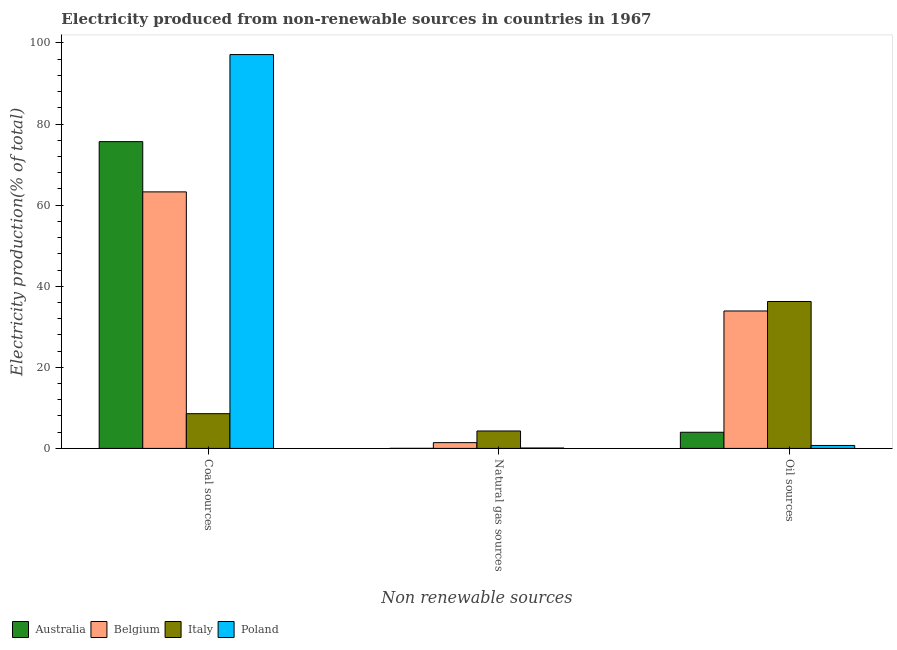Are the number of bars on each tick of the X-axis equal?
Provide a short and direct response. Yes. How many bars are there on the 2nd tick from the right?
Provide a short and direct response. 4. What is the label of the 2nd group of bars from the left?
Provide a short and direct response. Natural gas sources. What is the percentage of electricity produced by coal in Poland?
Your answer should be compact. 97.14. Across all countries, what is the maximum percentage of electricity produced by coal?
Keep it short and to the point. 97.14. Across all countries, what is the minimum percentage of electricity produced by oil sources?
Offer a terse response. 0.73. What is the total percentage of electricity produced by oil sources in the graph?
Keep it short and to the point. 74.85. What is the difference between the percentage of electricity produced by natural gas in Italy and that in Australia?
Your answer should be compact. 4.28. What is the difference between the percentage of electricity produced by coal in Belgium and the percentage of electricity produced by oil sources in Australia?
Offer a very short reply. 59.29. What is the average percentage of electricity produced by coal per country?
Your answer should be compact. 61.16. What is the difference between the percentage of electricity produced by coal and percentage of electricity produced by oil sources in Italy?
Keep it short and to the point. -27.67. In how many countries, is the percentage of electricity produced by oil sources greater than 80 %?
Give a very brief answer. 0. What is the ratio of the percentage of electricity produced by coal in Belgium to that in Poland?
Offer a terse response. 0.65. Is the difference between the percentage of electricity produced by oil sources in Italy and Poland greater than the difference between the percentage of electricity produced by coal in Italy and Poland?
Offer a terse response. Yes. What is the difference between the highest and the second highest percentage of electricity produced by natural gas?
Offer a very short reply. 2.87. What is the difference between the highest and the lowest percentage of electricity produced by natural gas?
Give a very brief answer. 4.28. In how many countries, is the percentage of electricity produced by oil sources greater than the average percentage of electricity produced by oil sources taken over all countries?
Keep it short and to the point. 2. Is the sum of the percentage of electricity produced by oil sources in Poland and Belgium greater than the maximum percentage of electricity produced by natural gas across all countries?
Your answer should be compact. Yes. What does the 3rd bar from the left in Natural gas sources represents?
Give a very brief answer. Italy. What does the 4th bar from the right in Coal sources represents?
Provide a short and direct response. Australia. How many bars are there?
Give a very brief answer. 12. How many countries are there in the graph?
Offer a very short reply. 4. Where does the legend appear in the graph?
Give a very brief answer. Bottom left. How many legend labels are there?
Provide a succinct answer. 4. How are the legend labels stacked?
Provide a succinct answer. Horizontal. What is the title of the graph?
Your answer should be very brief. Electricity produced from non-renewable sources in countries in 1967. What is the label or title of the X-axis?
Your response must be concise. Non renewable sources. What is the Electricity production(% of total) of Australia in Coal sources?
Ensure brevity in your answer.  75.67. What is the Electricity production(% of total) of Belgium in Coal sources?
Your answer should be very brief. 63.27. What is the Electricity production(% of total) of Italy in Coal sources?
Your answer should be very brief. 8.57. What is the Electricity production(% of total) of Poland in Coal sources?
Your response must be concise. 97.14. What is the Electricity production(% of total) of Australia in Natural gas sources?
Give a very brief answer. 0.02. What is the Electricity production(% of total) in Belgium in Natural gas sources?
Provide a short and direct response. 1.43. What is the Electricity production(% of total) in Italy in Natural gas sources?
Offer a very short reply. 4.3. What is the Electricity production(% of total) in Poland in Natural gas sources?
Offer a very short reply. 0.1. What is the Electricity production(% of total) of Australia in Oil sources?
Ensure brevity in your answer.  3.98. What is the Electricity production(% of total) in Belgium in Oil sources?
Ensure brevity in your answer.  33.9. What is the Electricity production(% of total) in Italy in Oil sources?
Give a very brief answer. 36.24. What is the Electricity production(% of total) in Poland in Oil sources?
Ensure brevity in your answer.  0.73. Across all Non renewable sources, what is the maximum Electricity production(% of total) in Australia?
Give a very brief answer. 75.67. Across all Non renewable sources, what is the maximum Electricity production(% of total) of Belgium?
Give a very brief answer. 63.27. Across all Non renewable sources, what is the maximum Electricity production(% of total) in Italy?
Ensure brevity in your answer.  36.24. Across all Non renewable sources, what is the maximum Electricity production(% of total) in Poland?
Give a very brief answer. 97.14. Across all Non renewable sources, what is the minimum Electricity production(% of total) in Australia?
Your answer should be compact. 0.02. Across all Non renewable sources, what is the minimum Electricity production(% of total) of Belgium?
Give a very brief answer. 1.43. Across all Non renewable sources, what is the minimum Electricity production(% of total) of Italy?
Keep it short and to the point. 4.3. Across all Non renewable sources, what is the minimum Electricity production(% of total) of Poland?
Offer a terse response. 0.1. What is the total Electricity production(% of total) of Australia in the graph?
Make the answer very short. 79.67. What is the total Electricity production(% of total) in Belgium in the graph?
Offer a terse response. 98.6. What is the total Electricity production(% of total) in Italy in the graph?
Provide a succinct answer. 49.11. What is the total Electricity production(% of total) in Poland in the graph?
Make the answer very short. 97.97. What is the difference between the Electricity production(% of total) in Australia in Coal sources and that in Natural gas sources?
Your answer should be very brief. 75.65. What is the difference between the Electricity production(% of total) of Belgium in Coal sources and that in Natural gas sources?
Keep it short and to the point. 61.85. What is the difference between the Electricity production(% of total) of Italy in Coal sources and that in Natural gas sources?
Provide a short and direct response. 4.27. What is the difference between the Electricity production(% of total) in Poland in Coal sources and that in Natural gas sources?
Your answer should be compact. 97.04. What is the difference between the Electricity production(% of total) in Australia in Coal sources and that in Oil sources?
Your response must be concise. 71.68. What is the difference between the Electricity production(% of total) in Belgium in Coal sources and that in Oil sources?
Your answer should be compact. 29.37. What is the difference between the Electricity production(% of total) in Italy in Coal sources and that in Oil sources?
Your answer should be very brief. -27.67. What is the difference between the Electricity production(% of total) in Poland in Coal sources and that in Oil sources?
Provide a succinct answer. 96.41. What is the difference between the Electricity production(% of total) of Australia in Natural gas sources and that in Oil sources?
Your answer should be compact. -3.96. What is the difference between the Electricity production(% of total) in Belgium in Natural gas sources and that in Oil sources?
Make the answer very short. -32.47. What is the difference between the Electricity production(% of total) of Italy in Natural gas sources and that in Oil sources?
Give a very brief answer. -31.94. What is the difference between the Electricity production(% of total) of Poland in Natural gas sources and that in Oil sources?
Offer a terse response. -0.63. What is the difference between the Electricity production(% of total) of Australia in Coal sources and the Electricity production(% of total) of Belgium in Natural gas sources?
Make the answer very short. 74.24. What is the difference between the Electricity production(% of total) of Australia in Coal sources and the Electricity production(% of total) of Italy in Natural gas sources?
Provide a short and direct response. 71.37. What is the difference between the Electricity production(% of total) of Australia in Coal sources and the Electricity production(% of total) of Poland in Natural gas sources?
Ensure brevity in your answer.  75.57. What is the difference between the Electricity production(% of total) of Belgium in Coal sources and the Electricity production(% of total) of Italy in Natural gas sources?
Provide a succinct answer. 58.97. What is the difference between the Electricity production(% of total) of Belgium in Coal sources and the Electricity production(% of total) of Poland in Natural gas sources?
Keep it short and to the point. 63.17. What is the difference between the Electricity production(% of total) in Italy in Coal sources and the Electricity production(% of total) in Poland in Natural gas sources?
Offer a very short reply. 8.47. What is the difference between the Electricity production(% of total) in Australia in Coal sources and the Electricity production(% of total) in Belgium in Oil sources?
Give a very brief answer. 41.77. What is the difference between the Electricity production(% of total) in Australia in Coal sources and the Electricity production(% of total) in Italy in Oil sources?
Offer a terse response. 39.43. What is the difference between the Electricity production(% of total) of Australia in Coal sources and the Electricity production(% of total) of Poland in Oil sources?
Give a very brief answer. 74.94. What is the difference between the Electricity production(% of total) of Belgium in Coal sources and the Electricity production(% of total) of Italy in Oil sources?
Ensure brevity in your answer.  27.03. What is the difference between the Electricity production(% of total) in Belgium in Coal sources and the Electricity production(% of total) in Poland in Oil sources?
Your answer should be very brief. 62.54. What is the difference between the Electricity production(% of total) in Italy in Coal sources and the Electricity production(% of total) in Poland in Oil sources?
Your answer should be compact. 7.84. What is the difference between the Electricity production(% of total) in Australia in Natural gas sources and the Electricity production(% of total) in Belgium in Oil sources?
Your answer should be very brief. -33.88. What is the difference between the Electricity production(% of total) in Australia in Natural gas sources and the Electricity production(% of total) in Italy in Oil sources?
Keep it short and to the point. -36.22. What is the difference between the Electricity production(% of total) of Australia in Natural gas sources and the Electricity production(% of total) of Poland in Oil sources?
Offer a very short reply. -0.71. What is the difference between the Electricity production(% of total) of Belgium in Natural gas sources and the Electricity production(% of total) of Italy in Oil sources?
Your answer should be compact. -34.81. What is the difference between the Electricity production(% of total) in Belgium in Natural gas sources and the Electricity production(% of total) in Poland in Oil sources?
Your answer should be very brief. 0.7. What is the difference between the Electricity production(% of total) of Italy in Natural gas sources and the Electricity production(% of total) of Poland in Oil sources?
Your answer should be compact. 3.57. What is the average Electricity production(% of total) of Australia per Non renewable sources?
Offer a very short reply. 26.56. What is the average Electricity production(% of total) of Belgium per Non renewable sources?
Give a very brief answer. 32.87. What is the average Electricity production(% of total) in Italy per Non renewable sources?
Ensure brevity in your answer.  16.37. What is the average Electricity production(% of total) of Poland per Non renewable sources?
Keep it short and to the point. 32.66. What is the difference between the Electricity production(% of total) of Australia and Electricity production(% of total) of Belgium in Coal sources?
Offer a terse response. 12.39. What is the difference between the Electricity production(% of total) of Australia and Electricity production(% of total) of Italy in Coal sources?
Provide a short and direct response. 67.1. What is the difference between the Electricity production(% of total) in Australia and Electricity production(% of total) in Poland in Coal sources?
Your answer should be compact. -21.47. What is the difference between the Electricity production(% of total) in Belgium and Electricity production(% of total) in Italy in Coal sources?
Give a very brief answer. 54.7. What is the difference between the Electricity production(% of total) in Belgium and Electricity production(% of total) in Poland in Coal sources?
Provide a succinct answer. -33.87. What is the difference between the Electricity production(% of total) of Italy and Electricity production(% of total) of Poland in Coal sources?
Give a very brief answer. -88.57. What is the difference between the Electricity production(% of total) of Australia and Electricity production(% of total) of Belgium in Natural gas sources?
Make the answer very short. -1.41. What is the difference between the Electricity production(% of total) of Australia and Electricity production(% of total) of Italy in Natural gas sources?
Provide a short and direct response. -4.28. What is the difference between the Electricity production(% of total) of Australia and Electricity production(% of total) of Poland in Natural gas sources?
Your answer should be very brief. -0.08. What is the difference between the Electricity production(% of total) of Belgium and Electricity production(% of total) of Italy in Natural gas sources?
Give a very brief answer. -2.87. What is the difference between the Electricity production(% of total) of Belgium and Electricity production(% of total) of Poland in Natural gas sources?
Offer a terse response. 1.33. What is the difference between the Electricity production(% of total) of Italy and Electricity production(% of total) of Poland in Natural gas sources?
Make the answer very short. 4.2. What is the difference between the Electricity production(% of total) in Australia and Electricity production(% of total) in Belgium in Oil sources?
Your response must be concise. -29.91. What is the difference between the Electricity production(% of total) in Australia and Electricity production(% of total) in Italy in Oil sources?
Keep it short and to the point. -32.25. What is the difference between the Electricity production(% of total) in Australia and Electricity production(% of total) in Poland in Oil sources?
Make the answer very short. 3.25. What is the difference between the Electricity production(% of total) in Belgium and Electricity production(% of total) in Italy in Oil sources?
Ensure brevity in your answer.  -2.34. What is the difference between the Electricity production(% of total) of Belgium and Electricity production(% of total) of Poland in Oil sources?
Keep it short and to the point. 33.17. What is the difference between the Electricity production(% of total) of Italy and Electricity production(% of total) of Poland in Oil sources?
Offer a very short reply. 35.51. What is the ratio of the Electricity production(% of total) of Australia in Coal sources to that in Natural gas sources?
Ensure brevity in your answer.  3681.5. What is the ratio of the Electricity production(% of total) in Belgium in Coal sources to that in Natural gas sources?
Give a very brief answer. 44.35. What is the ratio of the Electricity production(% of total) in Italy in Coal sources to that in Natural gas sources?
Your answer should be compact. 1.99. What is the ratio of the Electricity production(% of total) of Poland in Coal sources to that in Natural gas sources?
Keep it short and to the point. 956.85. What is the ratio of the Electricity production(% of total) in Australia in Coal sources to that in Oil sources?
Provide a succinct answer. 18.99. What is the ratio of the Electricity production(% of total) of Belgium in Coal sources to that in Oil sources?
Make the answer very short. 1.87. What is the ratio of the Electricity production(% of total) in Italy in Coal sources to that in Oil sources?
Provide a succinct answer. 0.24. What is the ratio of the Electricity production(% of total) in Poland in Coal sources to that in Oil sources?
Offer a terse response. 133.04. What is the ratio of the Electricity production(% of total) of Australia in Natural gas sources to that in Oil sources?
Your answer should be very brief. 0.01. What is the ratio of the Electricity production(% of total) of Belgium in Natural gas sources to that in Oil sources?
Provide a succinct answer. 0.04. What is the ratio of the Electricity production(% of total) of Italy in Natural gas sources to that in Oil sources?
Your answer should be compact. 0.12. What is the ratio of the Electricity production(% of total) in Poland in Natural gas sources to that in Oil sources?
Offer a very short reply. 0.14. What is the difference between the highest and the second highest Electricity production(% of total) of Australia?
Your answer should be very brief. 71.68. What is the difference between the highest and the second highest Electricity production(% of total) of Belgium?
Your answer should be compact. 29.37. What is the difference between the highest and the second highest Electricity production(% of total) in Italy?
Give a very brief answer. 27.67. What is the difference between the highest and the second highest Electricity production(% of total) in Poland?
Your answer should be compact. 96.41. What is the difference between the highest and the lowest Electricity production(% of total) of Australia?
Offer a terse response. 75.65. What is the difference between the highest and the lowest Electricity production(% of total) in Belgium?
Make the answer very short. 61.85. What is the difference between the highest and the lowest Electricity production(% of total) in Italy?
Make the answer very short. 31.94. What is the difference between the highest and the lowest Electricity production(% of total) in Poland?
Provide a succinct answer. 97.04. 